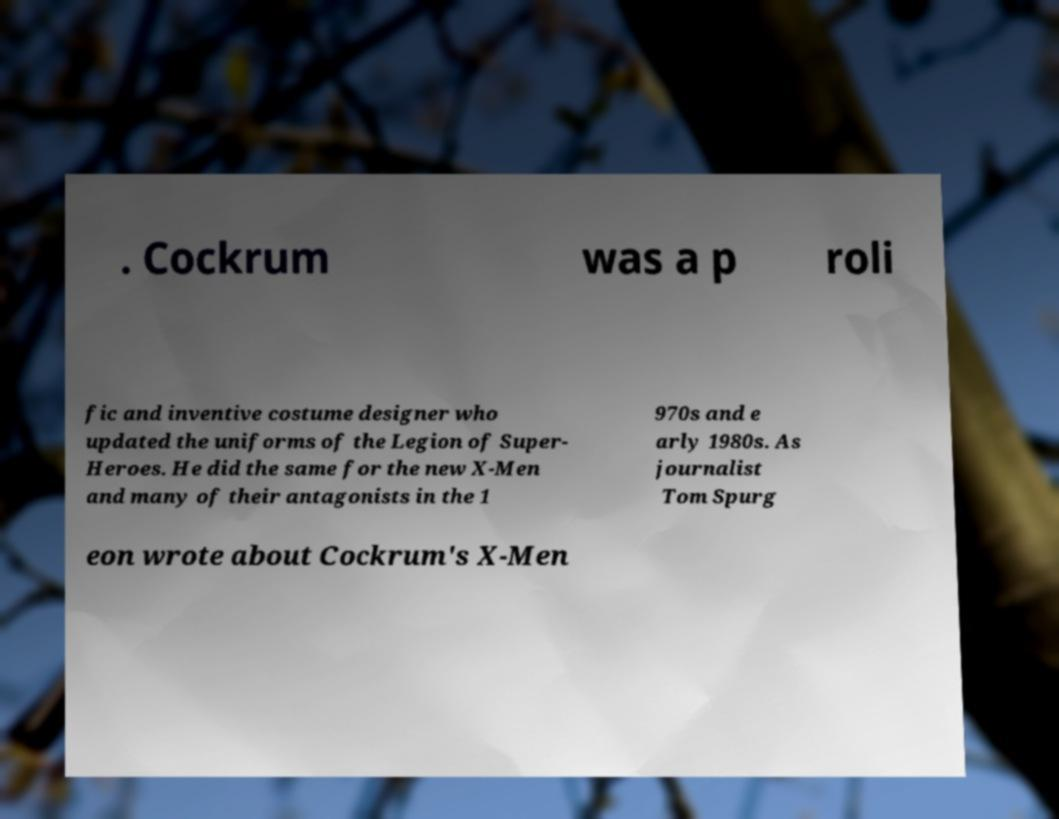Please identify and transcribe the text found in this image. . Cockrum was a p roli fic and inventive costume designer who updated the uniforms of the Legion of Super- Heroes. He did the same for the new X-Men and many of their antagonists in the 1 970s and e arly 1980s. As journalist Tom Spurg eon wrote about Cockrum's X-Men 